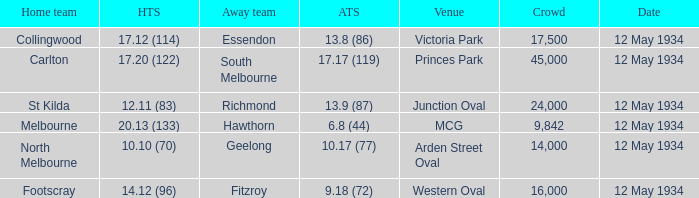What was the home teams score while playing the away team of south melbourne? 17.20 (122). 